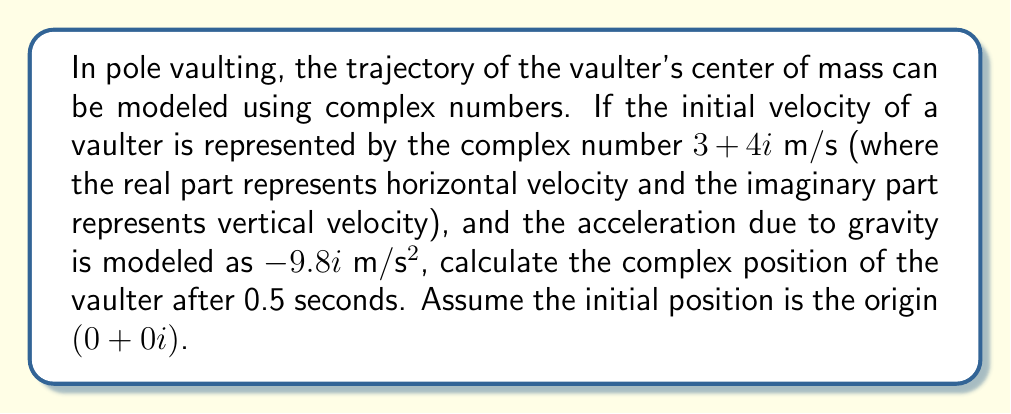Can you answer this question? Let's approach this step-by-step:

1) The position of an object under constant acceleration is given by the equation:
   $$s(t) = s_0 + v_0t + \frac{1}{2}at^2$$

   Where $s(t)$ is the position at time $t$, $s_0$ is the initial position, $v_0$ is the initial velocity, and $a$ is the acceleration.

2) In our case:
   $s_0 = 0 + 0i$ (starting at the origin)
   $v_0 = 3 + 4i$ m/s
   $a = 0 - 9.8i$ m/s² (only vertical acceleration due to gravity)
   $t = 0.5$ s

3) Let's substitute these into the equation:
   $$s(0.5) = (0 + 0i) + (3 + 4i)(0.5) + \frac{1}{2}(0 - 9.8i)(0.5)^2$$

4) Simplify:
   $$s(0.5) = (1.5 + 2i) + (0 - 1.225i)$$

5) Combine like terms:
   $$s(0.5) = 1.5 + 0.775i$$

Therefore, after 0.5 seconds, the vaulter's position can be represented by the complex number 1.5 + 0.775i meters.
Answer: $1.5 + 0.775i$ m 